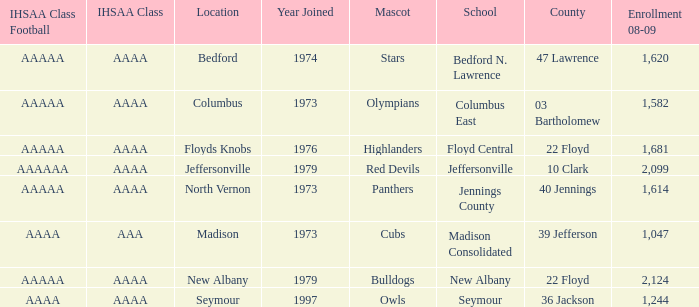What school is in 36 Jackson? Seymour. 